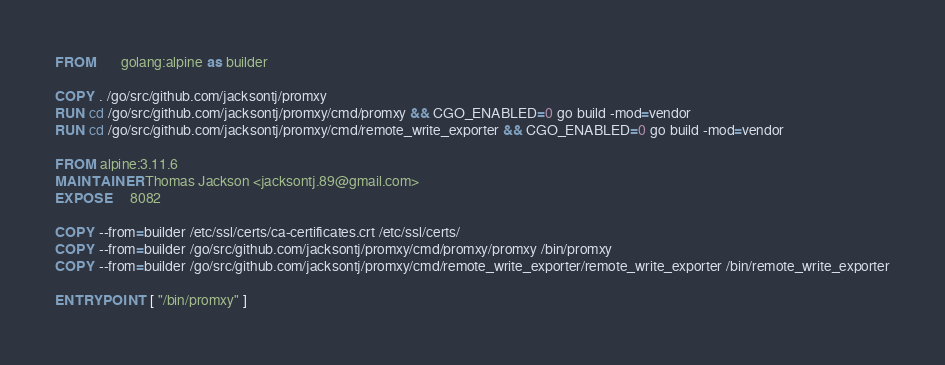Convert code to text. <code><loc_0><loc_0><loc_500><loc_500><_Dockerfile_>FROM       golang:alpine as builder

COPY . /go/src/github.com/jacksontj/promxy
RUN cd /go/src/github.com/jacksontj/promxy/cmd/promxy && CGO_ENABLED=0 go build -mod=vendor
RUN cd /go/src/github.com/jacksontj/promxy/cmd/remote_write_exporter && CGO_ENABLED=0 go build -mod=vendor

FROM alpine:3.11.6
MAINTAINER Thomas Jackson <jacksontj.89@gmail.com>
EXPOSE     8082

COPY --from=builder /etc/ssl/certs/ca-certificates.crt /etc/ssl/certs/
COPY --from=builder /go/src/github.com/jacksontj/promxy/cmd/promxy/promxy /bin/promxy
COPY --from=builder /go/src/github.com/jacksontj/promxy/cmd/remote_write_exporter/remote_write_exporter /bin/remote_write_exporter

ENTRYPOINT [ "/bin/promxy" ]

</code> 